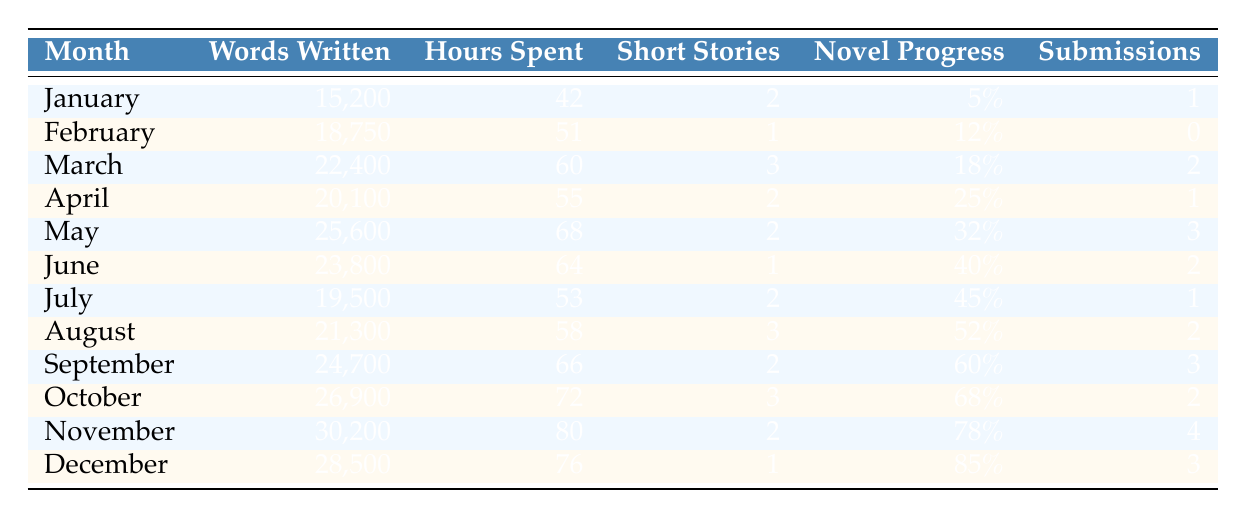What month had the highest number of words written? Scanning through the "Words Written" column, I see that November has the highest value at 30,200.
Answer: November How many short stories were completed in March? The table shows that 3 short stories were completed in March based on the corresponding row.
Answer: 3 What is the average number of hours spent writing each month? To find the average, I sum the hours spent each month: (42 + 51 + 60 + 55 + 68 + 64 + 53 + 58 + 66 + 72 + 80 + 76) = 708. There are 12 months, so the average is 708 / 12 = 59.
Answer: 59 Did the writing output (words written) increase every month? By comparing each consecutive month, I find that there are some instances where the number of words written did not increase (e.g., February to March). Thus, the statement is false.
Answer: No What is the total number of submissions over the year? Summing the "Submissions" column gives: (1 + 0 + 2 + 1 + 3 + 2 + 1 + 2 + 3 + 2 + 4 + 3) = 24.
Answer: 24 In which month did the novel progress reach 60% or more? I look at the "Novel Progress" percentages and identify that September, October, November, and December all have values at or above 60%.
Answer: September, October, November, December How many short stories were completed in total throughout the year? Adding the "Short Stories Completed" column results in: (2 + 1 + 3 + 2 + 2 + 1 + 2 + 3 + 2 + 3 + 2 + 1) = 23.
Answer: 23 Which month had the least amount of words written? Reviewing the "Words Written" entries, January has the lowest figure of 15,200.
Answer: January What is the difference in hours spent writing between the month with the highest and lowest hours? The most hours spent is in November (80), and the least is January (42). The difference is 80 - 42 = 38 hours.
Answer: 38 